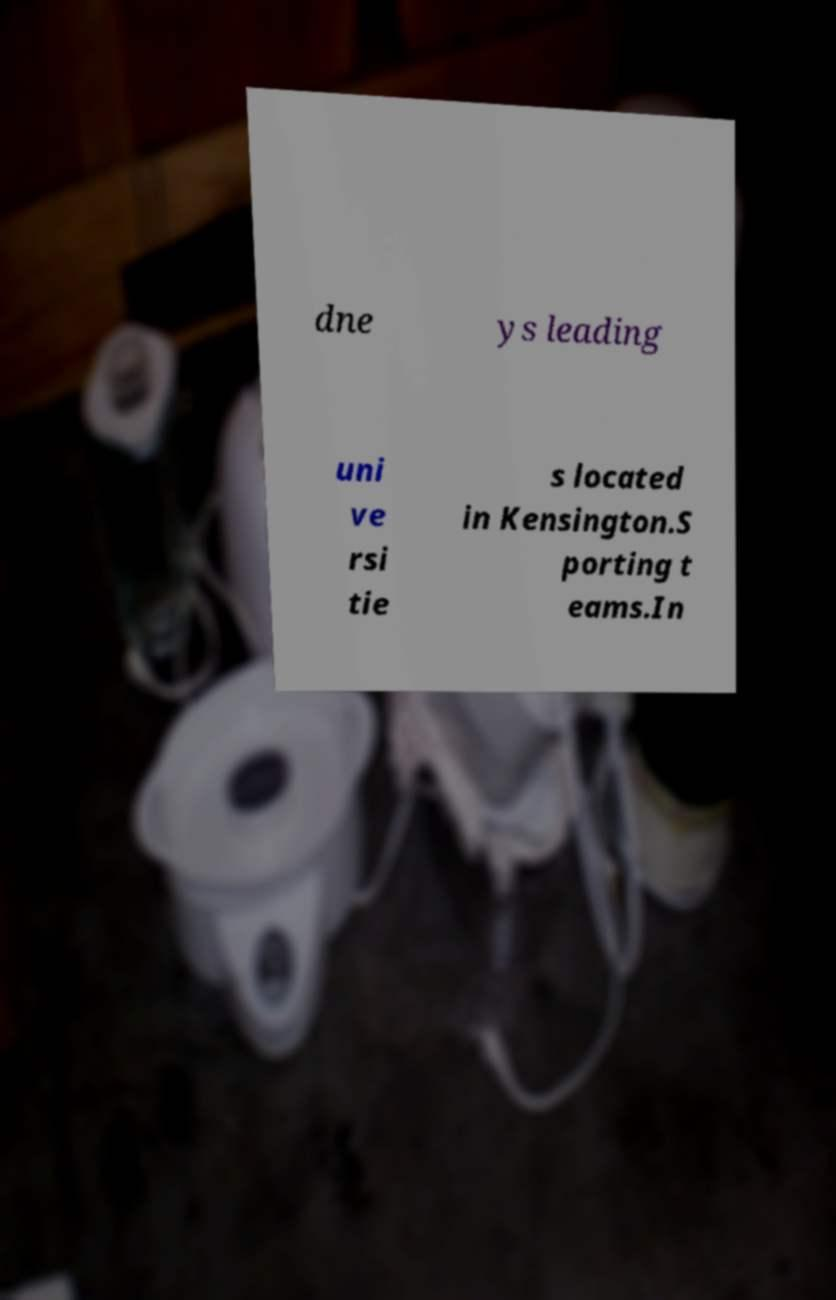Please identify and transcribe the text found in this image. dne ys leading uni ve rsi tie s located in Kensington.S porting t eams.In 